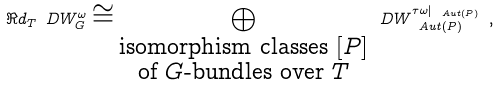<formula> <loc_0><loc_0><loc_500><loc_500>\Re d _ { T } \ D W _ { G } ^ { \omega } \cong \bigoplus _ { \substack { \text {isomorphism classes $[P]$} \\ \text {of $G$-bundles over $T$} } } \ D W _ { \ A u t ( P ) } ^ { \tau \omega | _ { \ A u t ( P ) } } \ ,</formula> 